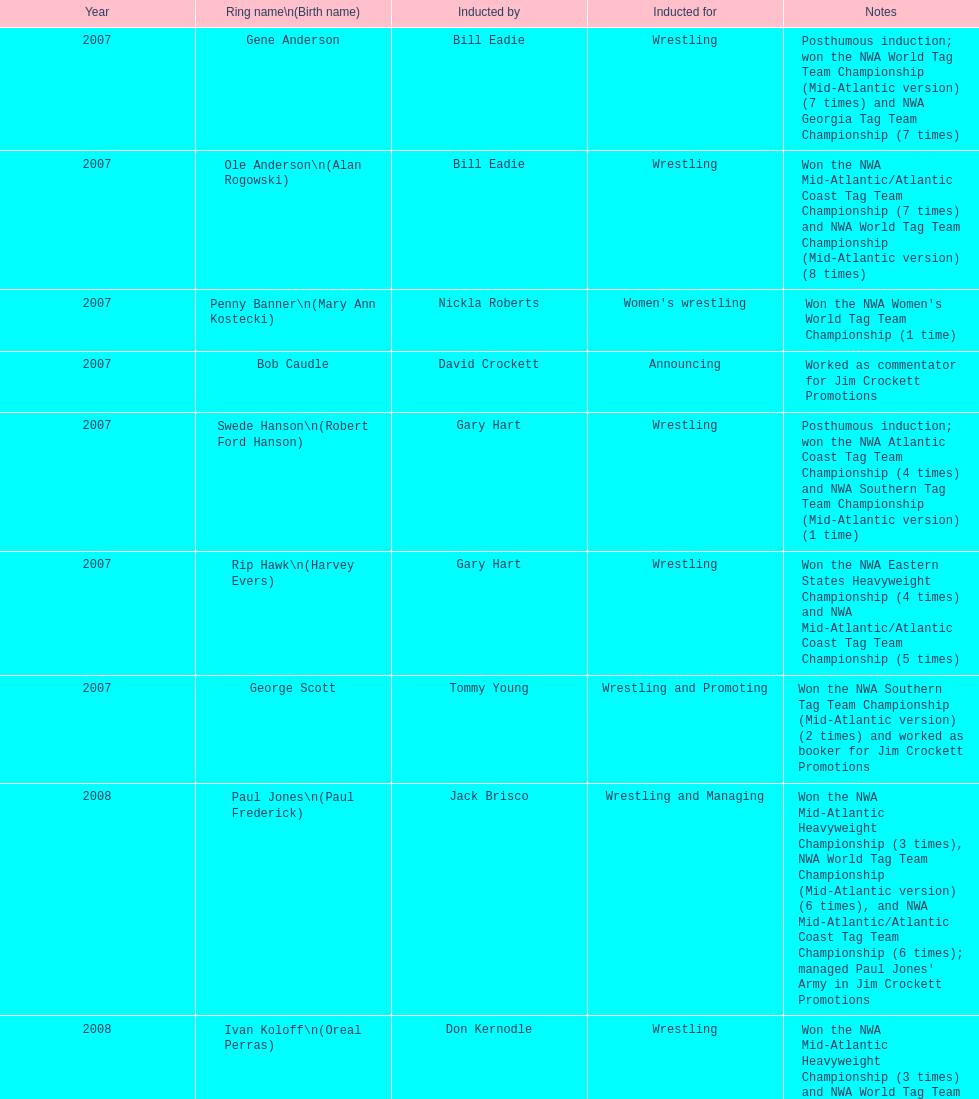Whose authentic name is dale hey, grizzly smith, or buddy roberts? Buddy Roberts. 